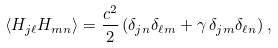<formula> <loc_0><loc_0><loc_500><loc_500>\langle H _ { j \ell } H _ { m n } \rangle = \frac { c ^ { 2 } } { 2 } \left ( \delta _ { j n } \delta _ { \ell m } + \gamma \, \delta _ { j m } \delta _ { \ell n } \right ) ,</formula> 